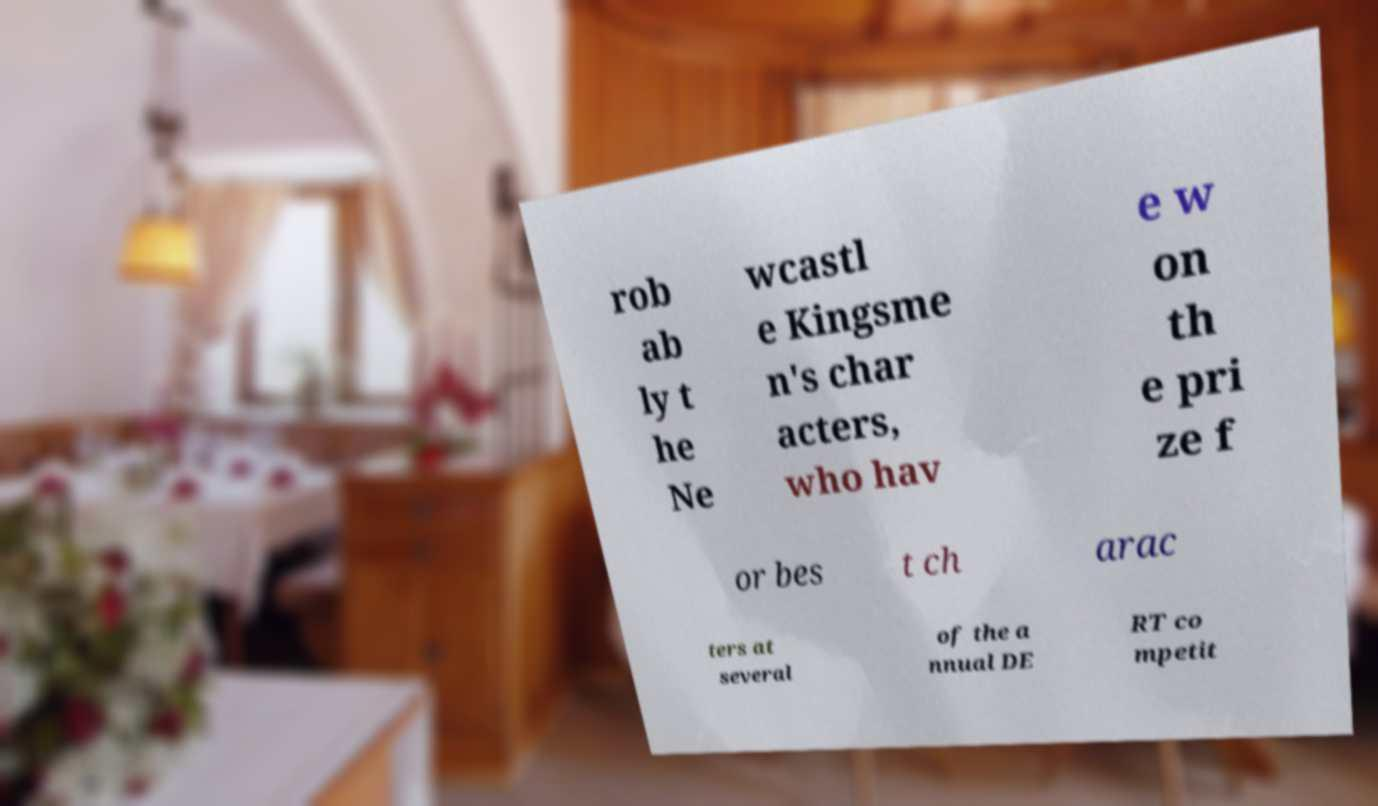Please read and relay the text visible in this image. What does it say? rob ab ly t he Ne wcastl e Kingsme n's char acters, who hav e w on th e pri ze f or bes t ch arac ters at several of the a nnual DE RT co mpetit 